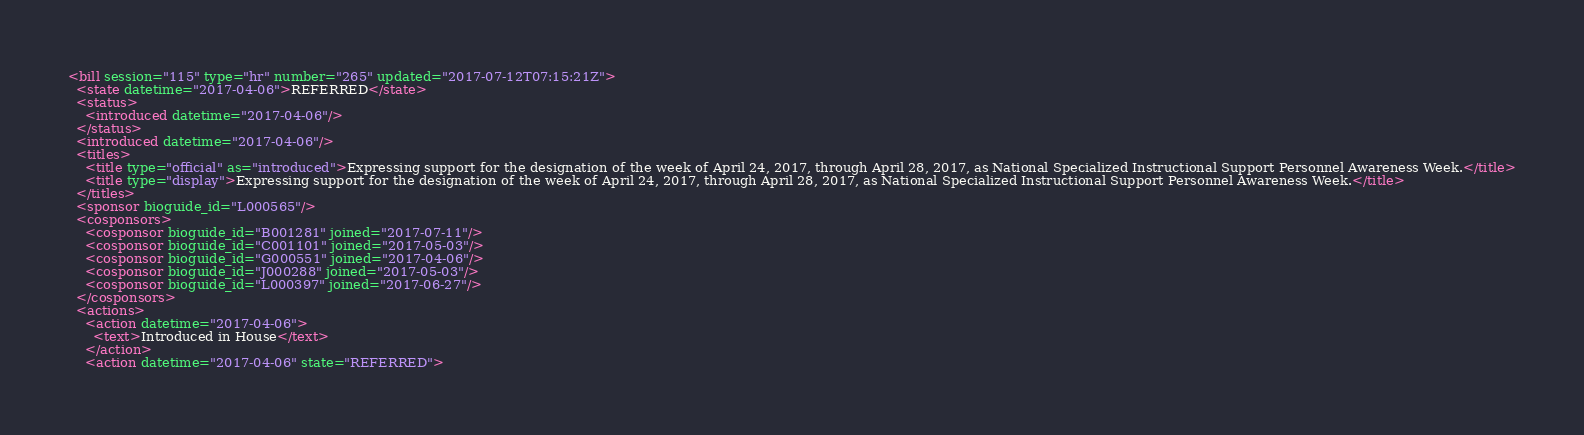<code> <loc_0><loc_0><loc_500><loc_500><_XML_><bill session="115" type="hr" number="265" updated="2017-07-12T07:15:21Z">
  <state datetime="2017-04-06">REFERRED</state>
  <status>
    <introduced datetime="2017-04-06"/>
  </status>
  <introduced datetime="2017-04-06"/>
  <titles>
    <title type="official" as="introduced">Expressing support for the designation of the week of April 24, 2017, through April 28, 2017, as National Specialized Instructional Support Personnel Awareness Week.</title>
    <title type="display">Expressing support for the designation of the week of April 24, 2017, through April 28, 2017, as National Specialized Instructional Support Personnel Awareness Week.</title>
  </titles>
  <sponsor bioguide_id="L000565"/>
  <cosponsors>
    <cosponsor bioguide_id="B001281" joined="2017-07-11"/>
    <cosponsor bioguide_id="C001101" joined="2017-05-03"/>
    <cosponsor bioguide_id="G000551" joined="2017-04-06"/>
    <cosponsor bioguide_id="J000288" joined="2017-05-03"/>
    <cosponsor bioguide_id="L000397" joined="2017-06-27"/>
  </cosponsors>
  <actions>
    <action datetime="2017-04-06">
      <text>Introduced in House</text>
    </action>
    <action datetime="2017-04-06" state="REFERRED"></code> 